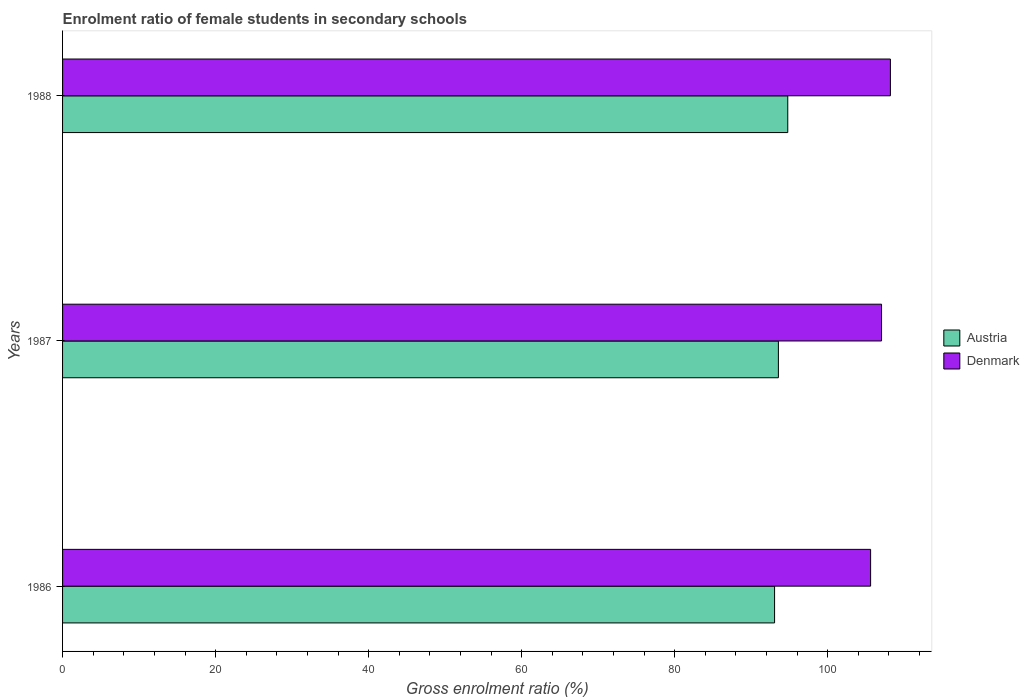How many groups of bars are there?
Keep it short and to the point. 3. What is the enrolment ratio of female students in secondary schools in Austria in 1987?
Provide a succinct answer. 93.55. Across all years, what is the maximum enrolment ratio of female students in secondary schools in Austria?
Your answer should be very brief. 94.78. Across all years, what is the minimum enrolment ratio of female students in secondary schools in Austria?
Keep it short and to the point. 93.05. In which year was the enrolment ratio of female students in secondary schools in Austria maximum?
Provide a short and direct response. 1988. What is the total enrolment ratio of female students in secondary schools in Denmark in the graph?
Provide a succinct answer. 320.83. What is the difference between the enrolment ratio of female students in secondary schools in Denmark in 1986 and that in 1988?
Your answer should be compact. -2.59. What is the difference between the enrolment ratio of female students in secondary schools in Austria in 1987 and the enrolment ratio of female students in secondary schools in Denmark in 1986?
Make the answer very short. -12.05. What is the average enrolment ratio of female students in secondary schools in Austria per year?
Keep it short and to the point. 93.79. In the year 1986, what is the difference between the enrolment ratio of female students in secondary schools in Denmark and enrolment ratio of female students in secondary schools in Austria?
Offer a terse response. 12.55. What is the ratio of the enrolment ratio of female students in secondary schools in Austria in 1987 to that in 1988?
Offer a very short reply. 0.99. Is the enrolment ratio of female students in secondary schools in Denmark in 1986 less than that in 1987?
Make the answer very short. Yes. What is the difference between the highest and the second highest enrolment ratio of female students in secondary schools in Austria?
Offer a very short reply. 1.23. What is the difference between the highest and the lowest enrolment ratio of female students in secondary schools in Denmark?
Your answer should be compact. 2.59. In how many years, is the enrolment ratio of female students in secondary schools in Austria greater than the average enrolment ratio of female students in secondary schools in Austria taken over all years?
Provide a succinct answer. 1. Is the sum of the enrolment ratio of female students in secondary schools in Austria in 1986 and 1988 greater than the maximum enrolment ratio of female students in secondary schools in Denmark across all years?
Make the answer very short. Yes. What does the 2nd bar from the bottom in 1987 represents?
Your answer should be compact. Denmark. How many bars are there?
Keep it short and to the point. 6. How many years are there in the graph?
Provide a short and direct response. 3. Does the graph contain grids?
Your answer should be very brief. No. Where does the legend appear in the graph?
Give a very brief answer. Center right. How are the legend labels stacked?
Your answer should be very brief. Vertical. What is the title of the graph?
Your answer should be compact. Enrolment ratio of female students in secondary schools. Does "El Salvador" appear as one of the legend labels in the graph?
Give a very brief answer. No. What is the Gross enrolment ratio (%) in Austria in 1986?
Offer a very short reply. 93.05. What is the Gross enrolment ratio (%) in Denmark in 1986?
Offer a terse response. 105.6. What is the Gross enrolment ratio (%) of Austria in 1987?
Your answer should be very brief. 93.55. What is the Gross enrolment ratio (%) of Denmark in 1987?
Offer a terse response. 107.03. What is the Gross enrolment ratio (%) in Austria in 1988?
Your answer should be compact. 94.78. What is the Gross enrolment ratio (%) in Denmark in 1988?
Provide a short and direct response. 108.19. Across all years, what is the maximum Gross enrolment ratio (%) of Austria?
Offer a very short reply. 94.78. Across all years, what is the maximum Gross enrolment ratio (%) in Denmark?
Your response must be concise. 108.19. Across all years, what is the minimum Gross enrolment ratio (%) in Austria?
Your response must be concise. 93.05. Across all years, what is the minimum Gross enrolment ratio (%) in Denmark?
Offer a terse response. 105.6. What is the total Gross enrolment ratio (%) in Austria in the graph?
Keep it short and to the point. 281.38. What is the total Gross enrolment ratio (%) in Denmark in the graph?
Keep it short and to the point. 320.83. What is the difference between the Gross enrolment ratio (%) of Austria in 1986 and that in 1987?
Offer a terse response. -0.5. What is the difference between the Gross enrolment ratio (%) in Denmark in 1986 and that in 1987?
Keep it short and to the point. -1.43. What is the difference between the Gross enrolment ratio (%) of Austria in 1986 and that in 1988?
Offer a very short reply. -1.72. What is the difference between the Gross enrolment ratio (%) in Denmark in 1986 and that in 1988?
Provide a short and direct response. -2.59. What is the difference between the Gross enrolment ratio (%) in Austria in 1987 and that in 1988?
Provide a succinct answer. -1.23. What is the difference between the Gross enrolment ratio (%) of Denmark in 1987 and that in 1988?
Your answer should be very brief. -1.16. What is the difference between the Gross enrolment ratio (%) in Austria in 1986 and the Gross enrolment ratio (%) in Denmark in 1987?
Offer a terse response. -13.98. What is the difference between the Gross enrolment ratio (%) of Austria in 1986 and the Gross enrolment ratio (%) of Denmark in 1988?
Your answer should be very brief. -15.14. What is the difference between the Gross enrolment ratio (%) of Austria in 1987 and the Gross enrolment ratio (%) of Denmark in 1988?
Keep it short and to the point. -14.64. What is the average Gross enrolment ratio (%) in Austria per year?
Your answer should be compact. 93.79. What is the average Gross enrolment ratio (%) in Denmark per year?
Give a very brief answer. 106.94. In the year 1986, what is the difference between the Gross enrolment ratio (%) in Austria and Gross enrolment ratio (%) in Denmark?
Provide a short and direct response. -12.55. In the year 1987, what is the difference between the Gross enrolment ratio (%) in Austria and Gross enrolment ratio (%) in Denmark?
Ensure brevity in your answer.  -13.48. In the year 1988, what is the difference between the Gross enrolment ratio (%) of Austria and Gross enrolment ratio (%) of Denmark?
Offer a very short reply. -13.41. What is the ratio of the Gross enrolment ratio (%) in Denmark in 1986 to that in 1987?
Keep it short and to the point. 0.99. What is the ratio of the Gross enrolment ratio (%) in Austria in 1986 to that in 1988?
Your answer should be very brief. 0.98. What is the ratio of the Gross enrolment ratio (%) in Denmark in 1986 to that in 1988?
Keep it short and to the point. 0.98. What is the ratio of the Gross enrolment ratio (%) in Austria in 1987 to that in 1988?
Provide a succinct answer. 0.99. What is the ratio of the Gross enrolment ratio (%) of Denmark in 1987 to that in 1988?
Offer a very short reply. 0.99. What is the difference between the highest and the second highest Gross enrolment ratio (%) of Austria?
Offer a very short reply. 1.23. What is the difference between the highest and the second highest Gross enrolment ratio (%) of Denmark?
Your response must be concise. 1.16. What is the difference between the highest and the lowest Gross enrolment ratio (%) in Austria?
Keep it short and to the point. 1.72. What is the difference between the highest and the lowest Gross enrolment ratio (%) in Denmark?
Your answer should be very brief. 2.59. 